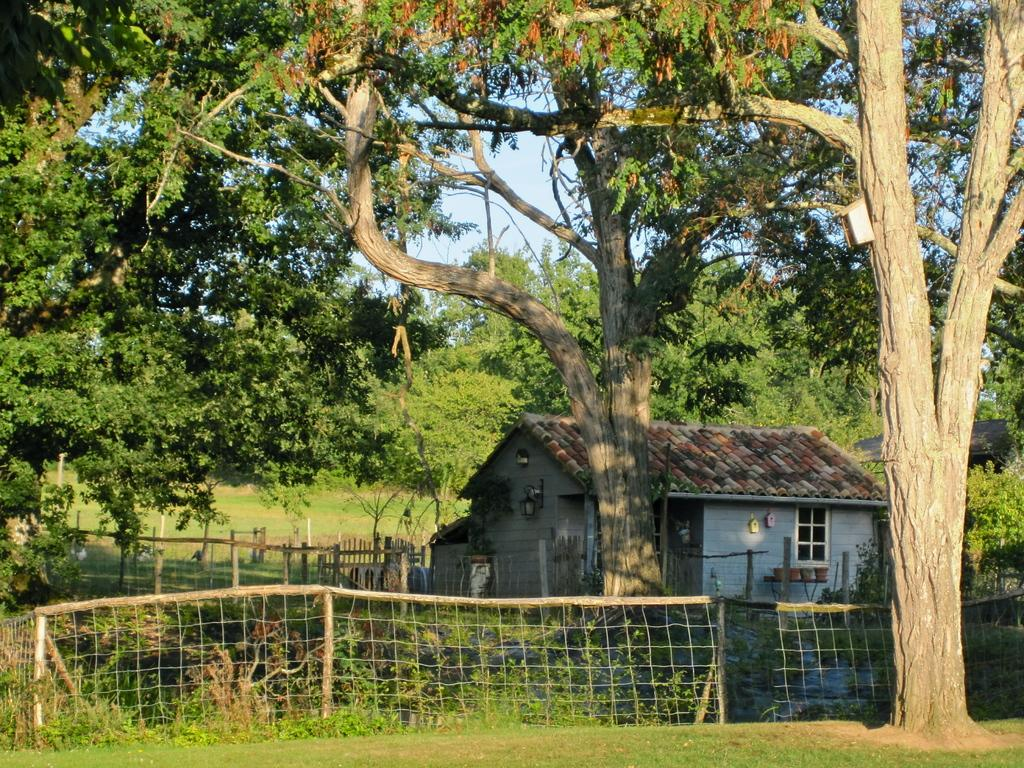What is located at the bottom of the image? There is fencing at the bottom of the image. What can be seen behind the fencing? There are plants and trees behind the fencing. What type of structure is visible behind the fencing? There is a house behind the fencing. What is visible at the top of the image? The sky is visible at the top of the image. Can you tell me how the plants and trees are providing a suggestion in the image? The plants and trees in the image are not providing any suggestions; they are simply part of the landscape. 